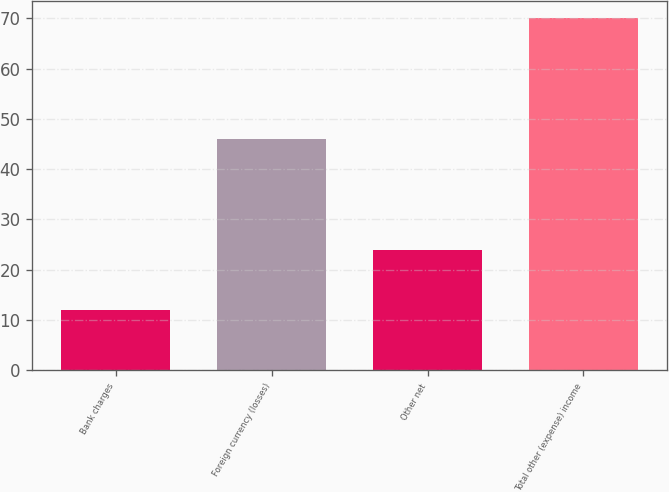Convert chart to OTSL. <chart><loc_0><loc_0><loc_500><loc_500><bar_chart><fcel>Bank charges<fcel>Foreign currency (losses)<fcel>Other net<fcel>Total other (expense) income<nl><fcel>12<fcel>46<fcel>24<fcel>70<nl></chart> 